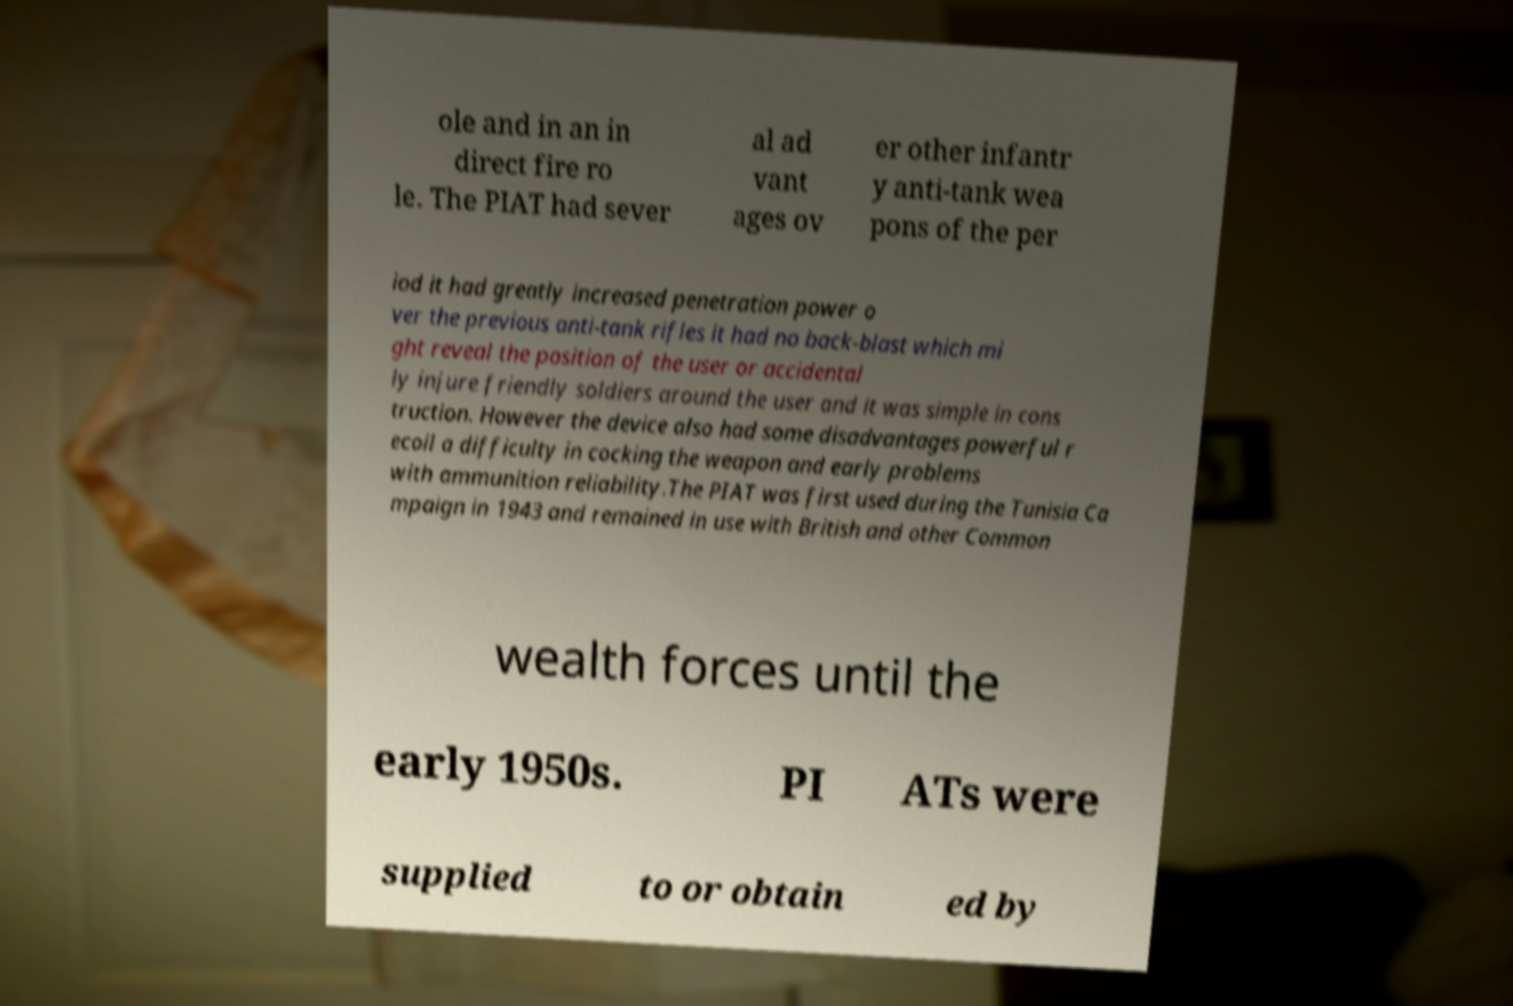Could you extract and type out the text from this image? ole and in an in direct fire ro le. The PIAT had sever al ad vant ages ov er other infantr y anti-tank wea pons of the per iod it had greatly increased penetration power o ver the previous anti-tank rifles it had no back-blast which mi ght reveal the position of the user or accidental ly injure friendly soldiers around the user and it was simple in cons truction. However the device also had some disadvantages powerful r ecoil a difficulty in cocking the weapon and early problems with ammunition reliability.The PIAT was first used during the Tunisia Ca mpaign in 1943 and remained in use with British and other Common wealth forces until the early 1950s. PI ATs were supplied to or obtain ed by 